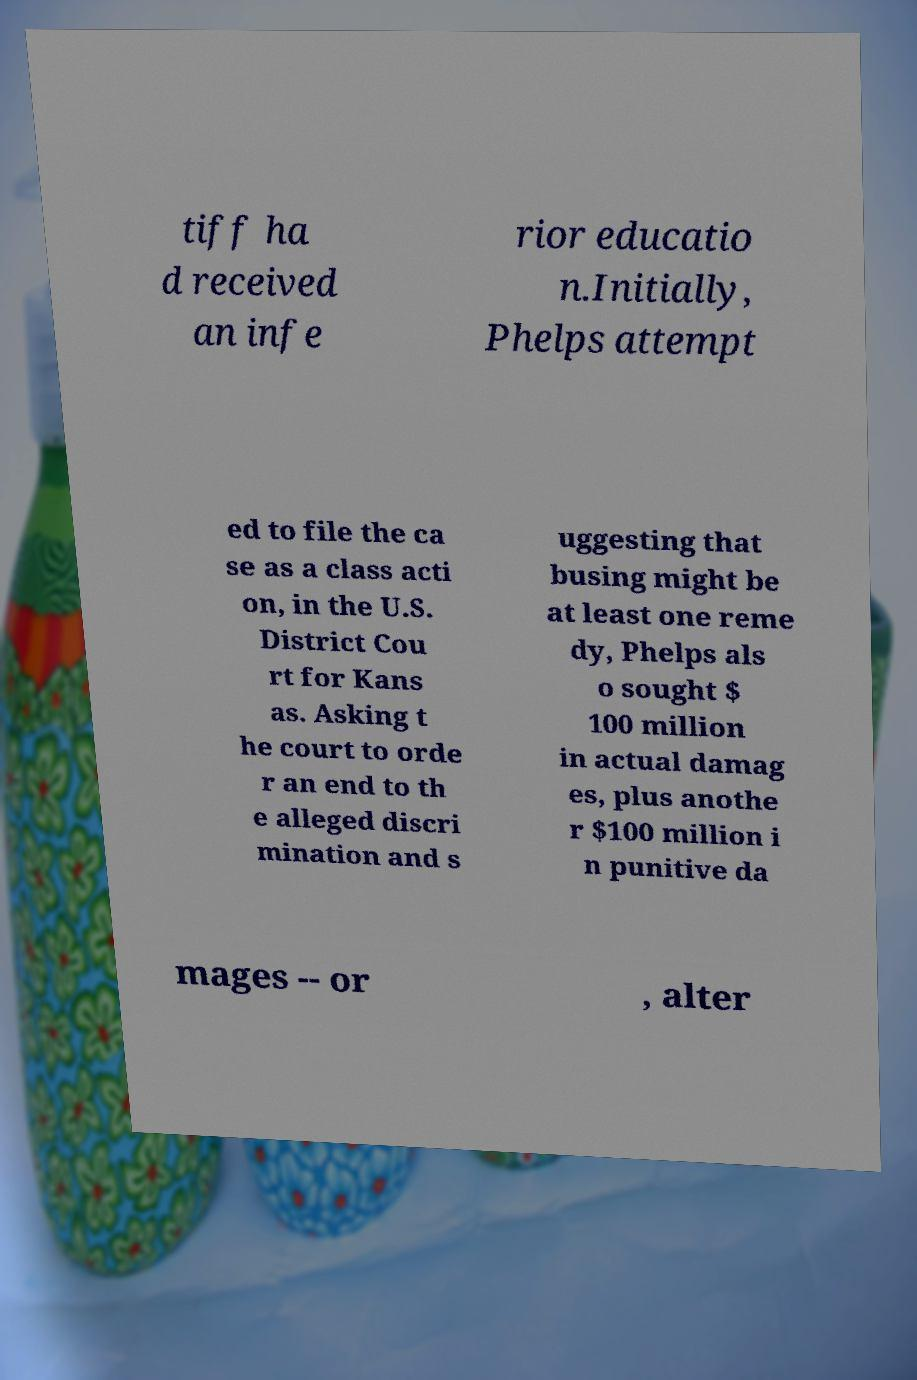Please read and relay the text visible in this image. What does it say? tiff ha d received an infe rior educatio n.Initially, Phelps attempt ed to file the ca se as a class acti on, in the U.S. District Cou rt for Kans as. Asking t he court to orde r an end to th e alleged discri mination and s uggesting that busing might be at least one reme dy, Phelps als o sought $ 100 million in actual damag es, plus anothe r $100 million i n punitive da mages -- or , alter 